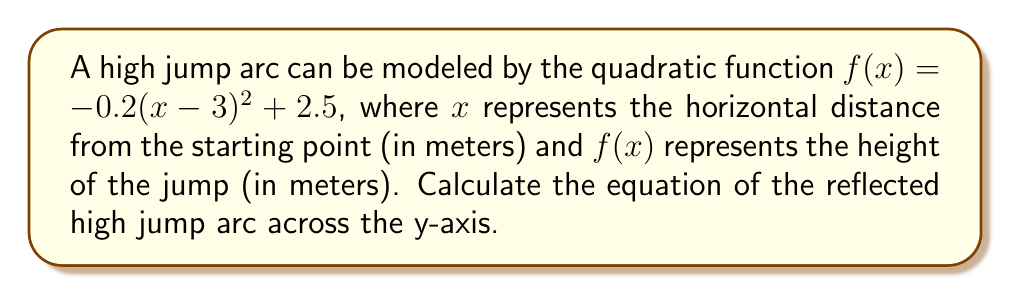Can you answer this question? To reflect the function across the y-axis, we need to replace every $x$ with $-x$ in the original function. Let's do this step-by-step:

1) The original function is:
   $f(x)=-0.2(x-3)^2+2.5$

2) Replace $x$ with $-x$:
   $g(x)=-0.2((-x)-3)^2+2.5$

3) Simplify the expression inside the parentheses:
   $g(x)=-0.2(-x-3)^2+2.5$

4) Distribute the negative sign:
   $g(x)=-0.2(x+3)^2+2.5$

This is the equation of the reflected high jump arc across the y-axis. The vertex of the parabola has moved from $(3, 2.5)$ to $(-3, 2.5)$, which is symmetric to the original vertex with respect to the y-axis.
Answer: $g(x)=-0.2(x+3)^2+2.5$ 